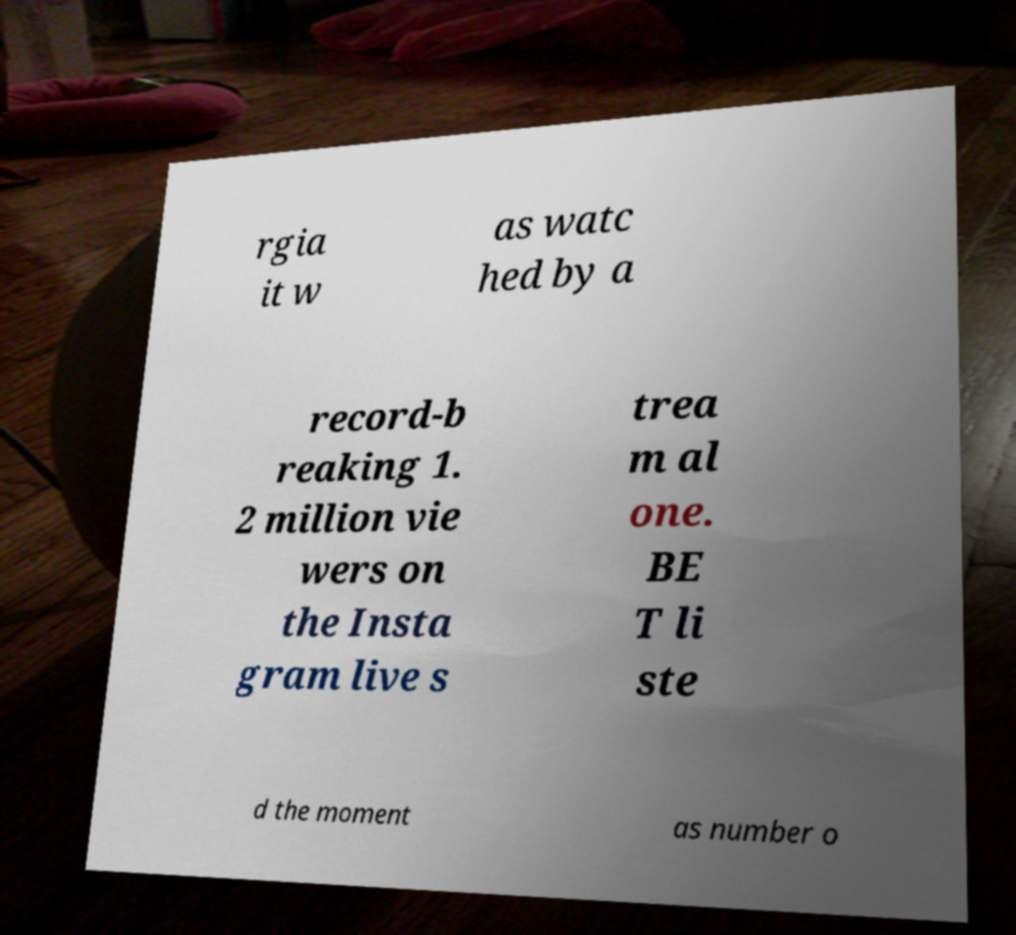I need the written content from this picture converted into text. Can you do that? rgia it w as watc hed by a record-b reaking 1. 2 million vie wers on the Insta gram live s trea m al one. BE T li ste d the moment as number o 